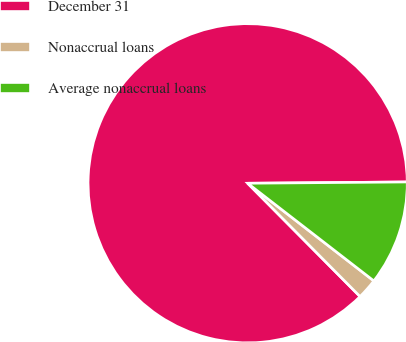<chart> <loc_0><loc_0><loc_500><loc_500><pie_chart><fcel>December 31<fcel>Nonaccrual loans<fcel>Average nonaccrual loans<nl><fcel>87.31%<fcel>2.08%<fcel>10.61%<nl></chart> 